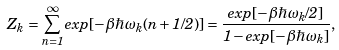<formula> <loc_0><loc_0><loc_500><loc_500>Z _ { k } = \sum _ { n = 1 } ^ { \infty } e x p [ - \beta \hbar { \omega } _ { k } ( n + 1 / 2 ) ] = \frac { e x p [ - \beta \hbar { \omega } _ { k } / 2 ] } { 1 - e x p [ - \beta \hbar { \omega } _ { k } ] } ,</formula> 